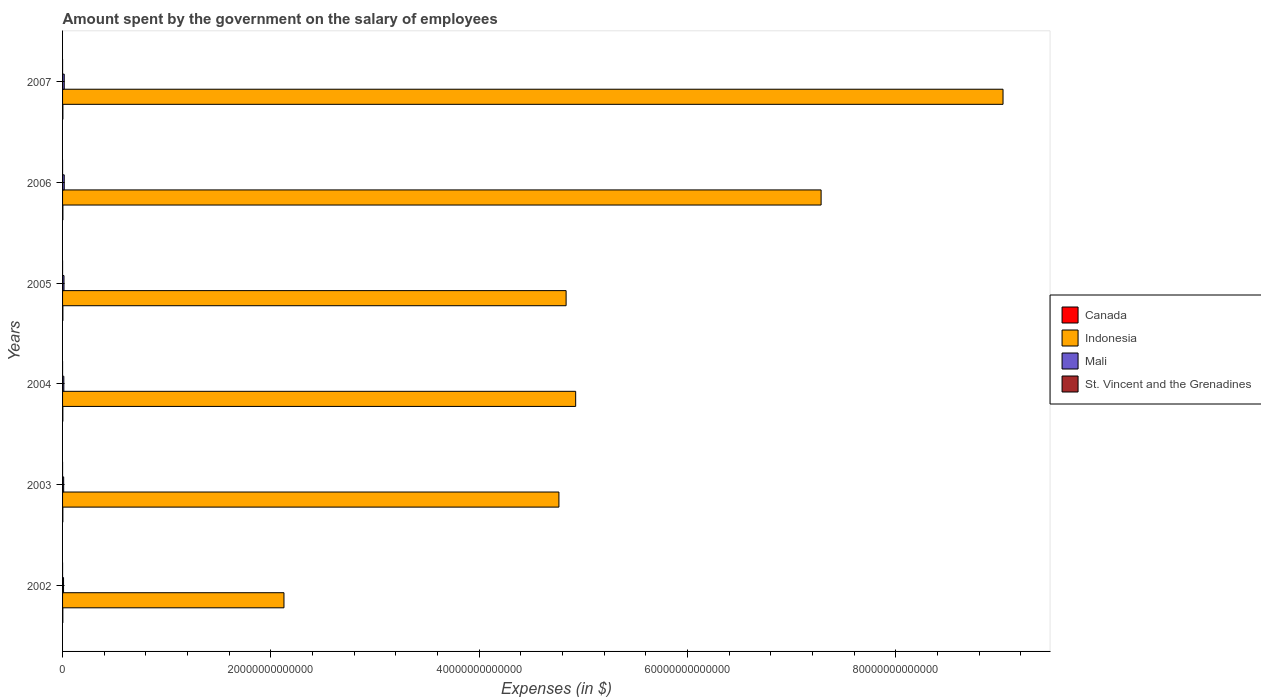How many bars are there on the 5th tick from the bottom?
Offer a very short reply. 4. In how many cases, is the number of bars for a given year not equal to the number of legend labels?
Your answer should be very brief. 0. What is the amount spent on the salary of employees by the government in Mali in 2005?
Your answer should be compact. 1.38e+11. Across all years, what is the maximum amount spent on the salary of employees by the government in Mali?
Keep it short and to the point. 1.60e+11. Across all years, what is the minimum amount spent on the salary of employees by the government in Canada?
Ensure brevity in your answer.  2.49e+1. In which year was the amount spent on the salary of employees by the government in Mali maximum?
Offer a very short reply. 2007. What is the total amount spent on the salary of employees by the government in St. Vincent and the Grenadines in the graph?
Give a very brief answer. 9.42e+08. What is the difference between the amount spent on the salary of employees by the government in Canada in 2003 and that in 2007?
Keep it short and to the point. -5.54e+09. What is the difference between the amount spent on the salary of employees by the government in Mali in 2006 and the amount spent on the salary of employees by the government in Indonesia in 2005?
Your response must be concise. -4.82e+13. What is the average amount spent on the salary of employees by the government in St. Vincent and the Grenadines per year?
Keep it short and to the point. 1.57e+08. In the year 2004, what is the difference between the amount spent on the salary of employees by the government in Canada and amount spent on the salary of employees by the government in Indonesia?
Ensure brevity in your answer.  -4.92e+13. What is the ratio of the amount spent on the salary of employees by the government in St. Vincent and the Grenadines in 2002 to that in 2005?
Ensure brevity in your answer.  0.87. Is the amount spent on the salary of employees by the government in St. Vincent and the Grenadines in 2006 less than that in 2007?
Provide a succinct answer. Yes. Is the difference between the amount spent on the salary of employees by the government in Canada in 2005 and 2006 greater than the difference between the amount spent on the salary of employees by the government in Indonesia in 2005 and 2006?
Make the answer very short. Yes. What is the difference between the highest and the second highest amount spent on the salary of employees by the government in St. Vincent and the Grenadines?
Your answer should be very brief. 1.77e+07. What is the difference between the highest and the lowest amount spent on the salary of employees by the government in Indonesia?
Your answer should be very brief. 6.90e+13. Is the sum of the amount spent on the salary of employees by the government in Mali in 2005 and 2007 greater than the maximum amount spent on the salary of employees by the government in Indonesia across all years?
Ensure brevity in your answer.  No. Is it the case that in every year, the sum of the amount spent on the salary of employees by the government in Mali and amount spent on the salary of employees by the government in Indonesia is greater than the sum of amount spent on the salary of employees by the government in St. Vincent and the Grenadines and amount spent on the salary of employees by the government in Canada?
Offer a very short reply. No. What does the 2nd bar from the top in 2007 represents?
Keep it short and to the point. Mali. Is it the case that in every year, the sum of the amount spent on the salary of employees by the government in St. Vincent and the Grenadines and amount spent on the salary of employees by the government in Canada is greater than the amount spent on the salary of employees by the government in Indonesia?
Your answer should be very brief. No. How many years are there in the graph?
Provide a short and direct response. 6. What is the difference between two consecutive major ticks on the X-axis?
Ensure brevity in your answer.  2.00e+13. Are the values on the major ticks of X-axis written in scientific E-notation?
Keep it short and to the point. No. Does the graph contain grids?
Keep it short and to the point. No. What is the title of the graph?
Offer a terse response. Amount spent by the government on the salary of employees. What is the label or title of the X-axis?
Make the answer very short. Expenses (in $). What is the Expenses (in $) of Canada in 2002?
Offer a terse response. 2.49e+1. What is the Expenses (in $) of Indonesia in 2002?
Provide a short and direct response. 2.13e+13. What is the Expenses (in $) of Mali in 2002?
Give a very brief answer. 9.35e+1. What is the Expenses (in $) in St. Vincent and the Grenadines in 2002?
Make the answer very short. 1.38e+08. What is the Expenses (in $) in Canada in 2003?
Your answer should be compact. 2.63e+1. What is the Expenses (in $) of Indonesia in 2003?
Provide a succinct answer. 4.77e+13. What is the Expenses (in $) of Mali in 2003?
Provide a short and direct response. 1.06e+11. What is the Expenses (in $) in St. Vincent and the Grenadines in 2003?
Offer a very short reply. 1.39e+08. What is the Expenses (in $) in Canada in 2004?
Give a very brief answer. 2.69e+1. What is the Expenses (in $) of Indonesia in 2004?
Provide a short and direct response. 4.93e+13. What is the Expenses (in $) of Mali in 2004?
Keep it short and to the point. 1.22e+11. What is the Expenses (in $) of St. Vincent and the Grenadines in 2004?
Your answer should be very brief. 1.45e+08. What is the Expenses (in $) in Canada in 2005?
Keep it short and to the point. 2.92e+1. What is the Expenses (in $) of Indonesia in 2005?
Offer a very short reply. 4.84e+13. What is the Expenses (in $) of Mali in 2005?
Provide a succinct answer. 1.38e+11. What is the Expenses (in $) of St. Vincent and the Grenadines in 2005?
Your response must be concise. 1.59e+08. What is the Expenses (in $) in Canada in 2006?
Your response must be concise. 3.06e+1. What is the Expenses (in $) of Indonesia in 2006?
Give a very brief answer. 7.28e+13. What is the Expenses (in $) of Mali in 2006?
Provide a succinct answer. 1.60e+11. What is the Expenses (in $) in St. Vincent and the Grenadines in 2006?
Offer a terse response. 1.71e+08. What is the Expenses (in $) of Canada in 2007?
Your answer should be compact. 3.18e+1. What is the Expenses (in $) of Indonesia in 2007?
Make the answer very short. 9.03e+13. What is the Expenses (in $) of Mali in 2007?
Give a very brief answer. 1.60e+11. What is the Expenses (in $) of St. Vincent and the Grenadines in 2007?
Your answer should be very brief. 1.89e+08. Across all years, what is the maximum Expenses (in $) in Canada?
Give a very brief answer. 3.18e+1. Across all years, what is the maximum Expenses (in $) of Indonesia?
Keep it short and to the point. 9.03e+13. Across all years, what is the maximum Expenses (in $) of Mali?
Your answer should be compact. 1.60e+11. Across all years, what is the maximum Expenses (in $) of St. Vincent and the Grenadines?
Ensure brevity in your answer.  1.89e+08. Across all years, what is the minimum Expenses (in $) in Canada?
Give a very brief answer. 2.49e+1. Across all years, what is the minimum Expenses (in $) of Indonesia?
Offer a very short reply. 2.13e+13. Across all years, what is the minimum Expenses (in $) in Mali?
Your response must be concise. 9.35e+1. Across all years, what is the minimum Expenses (in $) of St. Vincent and the Grenadines?
Keep it short and to the point. 1.38e+08. What is the total Expenses (in $) of Canada in the graph?
Make the answer very short. 1.70e+11. What is the total Expenses (in $) in Indonesia in the graph?
Offer a very short reply. 3.30e+14. What is the total Expenses (in $) of Mali in the graph?
Offer a terse response. 7.79e+11. What is the total Expenses (in $) of St. Vincent and the Grenadines in the graph?
Keep it short and to the point. 9.42e+08. What is the difference between the Expenses (in $) in Canada in 2002 and that in 2003?
Provide a short and direct response. -1.36e+09. What is the difference between the Expenses (in $) in Indonesia in 2002 and that in 2003?
Offer a terse response. -2.64e+13. What is the difference between the Expenses (in $) of Mali in 2002 and that in 2003?
Keep it short and to the point. -1.27e+1. What is the difference between the Expenses (in $) in St. Vincent and the Grenadines in 2002 and that in 2003?
Provide a short and direct response. -8.00e+05. What is the difference between the Expenses (in $) in Canada in 2002 and that in 2004?
Provide a succinct answer. -1.98e+09. What is the difference between the Expenses (in $) in Indonesia in 2002 and that in 2004?
Make the answer very short. -2.80e+13. What is the difference between the Expenses (in $) of Mali in 2002 and that in 2004?
Your answer should be very brief. -2.82e+1. What is the difference between the Expenses (in $) of St. Vincent and the Grenadines in 2002 and that in 2004?
Your response must be concise. -6.50e+06. What is the difference between the Expenses (in $) in Canada in 2002 and that in 2005?
Make the answer very short. -4.27e+09. What is the difference between the Expenses (in $) of Indonesia in 2002 and that in 2005?
Provide a succinct answer. -2.71e+13. What is the difference between the Expenses (in $) of Mali in 2002 and that in 2005?
Make the answer very short. -4.43e+1. What is the difference between the Expenses (in $) in St. Vincent and the Grenadines in 2002 and that in 2005?
Give a very brief answer. -2.08e+07. What is the difference between the Expenses (in $) in Canada in 2002 and that in 2006?
Your response must be concise. -5.63e+09. What is the difference between the Expenses (in $) of Indonesia in 2002 and that in 2006?
Your answer should be very brief. -5.16e+13. What is the difference between the Expenses (in $) in Mali in 2002 and that in 2006?
Offer a very short reply. -6.61e+1. What is the difference between the Expenses (in $) in St. Vincent and the Grenadines in 2002 and that in 2006?
Offer a terse response. -3.30e+07. What is the difference between the Expenses (in $) of Canada in 2002 and that in 2007?
Ensure brevity in your answer.  -6.90e+09. What is the difference between the Expenses (in $) in Indonesia in 2002 and that in 2007?
Your answer should be compact. -6.90e+13. What is the difference between the Expenses (in $) of Mali in 2002 and that in 2007?
Make the answer very short. -6.68e+1. What is the difference between the Expenses (in $) in St. Vincent and the Grenadines in 2002 and that in 2007?
Offer a terse response. -5.07e+07. What is the difference between the Expenses (in $) in Canada in 2003 and that in 2004?
Keep it short and to the point. -6.14e+08. What is the difference between the Expenses (in $) in Indonesia in 2003 and that in 2004?
Your response must be concise. -1.61e+12. What is the difference between the Expenses (in $) of Mali in 2003 and that in 2004?
Keep it short and to the point. -1.55e+1. What is the difference between the Expenses (in $) of St. Vincent and the Grenadines in 2003 and that in 2004?
Your response must be concise. -5.70e+06. What is the difference between the Expenses (in $) in Canada in 2003 and that in 2005?
Provide a succinct answer. -2.90e+09. What is the difference between the Expenses (in $) in Indonesia in 2003 and that in 2005?
Provide a short and direct response. -6.89e+11. What is the difference between the Expenses (in $) in Mali in 2003 and that in 2005?
Offer a very short reply. -3.16e+1. What is the difference between the Expenses (in $) in St. Vincent and the Grenadines in 2003 and that in 2005?
Ensure brevity in your answer.  -2.00e+07. What is the difference between the Expenses (in $) in Canada in 2003 and that in 2006?
Your response must be concise. -4.26e+09. What is the difference between the Expenses (in $) of Indonesia in 2003 and that in 2006?
Offer a terse response. -2.52e+13. What is the difference between the Expenses (in $) in Mali in 2003 and that in 2006?
Your answer should be very brief. -5.34e+1. What is the difference between the Expenses (in $) in St. Vincent and the Grenadines in 2003 and that in 2006?
Ensure brevity in your answer.  -3.22e+07. What is the difference between the Expenses (in $) in Canada in 2003 and that in 2007?
Give a very brief answer. -5.54e+09. What is the difference between the Expenses (in $) of Indonesia in 2003 and that in 2007?
Provide a succinct answer. -4.26e+13. What is the difference between the Expenses (in $) in Mali in 2003 and that in 2007?
Keep it short and to the point. -5.41e+1. What is the difference between the Expenses (in $) in St. Vincent and the Grenadines in 2003 and that in 2007?
Provide a succinct answer. -4.99e+07. What is the difference between the Expenses (in $) in Canada in 2004 and that in 2005?
Offer a very short reply. -2.29e+09. What is the difference between the Expenses (in $) in Indonesia in 2004 and that in 2005?
Give a very brief answer. 9.19e+11. What is the difference between the Expenses (in $) of Mali in 2004 and that in 2005?
Keep it short and to the point. -1.61e+1. What is the difference between the Expenses (in $) of St. Vincent and the Grenadines in 2004 and that in 2005?
Ensure brevity in your answer.  -1.43e+07. What is the difference between the Expenses (in $) of Canada in 2004 and that in 2006?
Your answer should be compact. -3.65e+09. What is the difference between the Expenses (in $) in Indonesia in 2004 and that in 2006?
Provide a short and direct response. -2.36e+13. What is the difference between the Expenses (in $) of Mali in 2004 and that in 2006?
Make the answer very short. -3.79e+1. What is the difference between the Expenses (in $) in St. Vincent and the Grenadines in 2004 and that in 2006?
Offer a terse response. -2.65e+07. What is the difference between the Expenses (in $) of Canada in 2004 and that in 2007?
Offer a terse response. -4.92e+09. What is the difference between the Expenses (in $) of Indonesia in 2004 and that in 2007?
Ensure brevity in your answer.  -4.10e+13. What is the difference between the Expenses (in $) of Mali in 2004 and that in 2007?
Make the answer very short. -3.86e+1. What is the difference between the Expenses (in $) in St. Vincent and the Grenadines in 2004 and that in 2007?
Keep it short and to the point. -4.42e+07. What is the difference between the Expenses (in $) in Canada in 2005 and that in 2006?
Your answer should be compact. -1.36e+09. What is the difference between the Expenses (in $) of Indonesia in 2005 and that in 2006?
Make the answer very short. -2.45e+13. What is the difference between the Expenses (in $) in Mali in 2005 and that in 2006?
Your response must be concise. -2.18e+1. What is the difference between the Expenses (in $) of St. Vincent and the Grenadines in 2005 and that in 2006?
Give a very brief answer. -1.22e+07. What is the difference between the Expenses (in $) of Canada in 2005 and that in 2007?
Your response must be concise. -2.63e+09. What is the difference between the Expenses (in $) of Indonesia in 2005 and that in 2007?
Make the answer very short. -4.20e+13. What is the difference between the Expenses (in $) in Mali in 2005 and that in 2007?
Keep it short and to the point. -2.25e+1. What is the difference between the Expenses (in $) in St. Vincent and the Grenadines in 2005 and that in 2007?
Provide a succinct answer. -2.99e+07. What is the difference between the Expenses (in $) in Canada in 2006 and that in 2007?
Your answer should be very brief. -1.27e+09. What is the difference between the Expenses (in $) in Indonesia in 2006 and that in 2007?
Your answer should be very brief. -1.75e+13. What is the difference between the Expenses (in $) of Mali in 2006 and that in 2007?
Offer a terse response. -7.02e+08. What is the difference between the Expenses (in $) of St. Vincent and the Grenadines in 2006 and that in 2007?
Keep it short and to the point. -1.77e+07. What is the difference between the Expenses (in $) in Canada in 2002 and the Expenses (in $) in Indonesia in 2003?
Ensure brevity in your answer.  -4.76e+13. What is the difference between the Expenses (in $) in Canada in 2002 and the Expenses (in $) in Mali in 2003?
Provide a succinct answer. -8.13e+1. What is the difference between the Expenses (in $) in Canada in 2002 and the Expenses (in $) in St. Vincent and the Grenadines in 2003?
Give a very brief answer. 2.48e+1. What is the difference between the Expenses (in $) of Indonesia in 2002 and the Expenses (in $) of Mali in 2003?
Provide a succinct answer. 2.12e+13. What is the difference between the Expenses (in $) of Indonesia in 2002 and the Expenses (in $) of St. Vincent and the Grenadines in 2003?
Offer a terse response. 2.13e+13. What is the difference between the Expenses (in $) of Mali in 2002 and the Expenses (in $) of St. Vincent and the Grenadines in 2003?
Give a very brief answer. 9.34e+1. What is the difference between the Expenses (in $) of Canada in 2002 and the Expenses (in $) of Indonesia in 2004?
Your response must be concise. -4.92e+13. What is the difference between the Expenses (in $) in Canada in 2002 and the Expenses (in $) in Mali in 2004?
Your answer should be compact. -9.68e+1. What is the difference between the Expenses (in $) of Canada in 2002 and the Expenses (in $) of St. Vincent and the Grenadines in 2004?
Your response must be concise. 2.48e+1. What is the difference between the Expenses (in $) of Indonesia in 2002 and the Expenses (in $) of Mali in 2004?
Ensure brevity in your answer.  2.11e+13. What is the difference between the Expenses (in $) of Indonesia in 2002 and the Expenses (in $) of St. Vincent and the Grenadines in 2004?
Ensure brevity in your answer.  2.13e+13. What is the difference between the Expenses (in $) of Mali in 2002 and the Expenses (in $) of St. Vincent and the Grenadines in 2004?
Your answer should be very brief. 9.33e+1. What is the difference between the Expenses (in $) in Canada in 2002 and the Expenses (in $) in Indonesia in 2005?
Offer a terse response. -4.83e+13. What is the difference between the Expenses (in $) of Canada in 2002 and the Expenses (in $) of Mali in 2005?
Provide a succinct answer. -1.13e+11. What is the difference between the Expenses (in $) in Canada in 2002 and the Expenses (in $) in St. Vincent and the Grenadines in 2005?
Keep it short and to the point. 2.48e+1. What is the difference between the Expenses (in $) in Indonesia in 2002 and the Expenses (in $) in Mali in 2005?
Provide a short and direct response. 2.11e+13. What is the difference between the Expenses (in $) in Indonesia in 2002 and the Expenses (in $) in St. Vincent and the Grenadines in 2005?
Your answer should be compact. 2.13e+13. What is the difference between the Expenses (in $) of Mali in 2002 and the Expenses (in $) of St. Vincent and the Grenadines in 2005?
Provide a short and direct response. 9.33e+1. What is the difference between the Expenses (in $) of Canada in 2002 and the Expenses (in $) of Indonesia in 2006?
Provide a short and direct response. -7.28e+13. What is the difference between the Expenses (in $) in Canada in 2002 and the Expenses (in $) in Mali in 2006?
Ensure brevity in your answer.  -1.35e+11. What is the difference between the Expenses (in $) of Canada in 2002 and the Expenses (in $) of St. Vincent and the Grenadines in 2006?
Provide a succinct answer. 2.48e+1. What is the difference between the Expenses (in $) of Indonesia in 2002 and the Expenses (in $) of Mali in 2006?
Your response must be concise. 2.11e+13. What is the difference between the Expenses (in $) in Indonesia in 2002 and the Expenses (in $) in St. Vincent and the Grenadines in 2006?
Offer a terse response. 2.13e+13. What is the difference between the Expenses (in $) in Mali in 2002 and the Expenses (in $) in St. Vincent and the Grenadines in 2006?
Ensure brevity in your answer.  9.33e+1. What is the difference between the Expenses (in $) in Canada in 2002 and the Expenses (in $) in Indonesia in 2007?
Offer a terse response. -9.03e+13. What is the difference between the Expenses (in $) of Canada in 2002 and the Expenses (in $) of Mali in 2007?
Your response must be concise. -1.35e+11. What is the difference between the Expenses (in $) of Canada in 2002 and the Expenses (in $) of St. Vincent and the Grenadines in 2007?
Offer a terse response. 2.48e+1. What is the difference between the Expenses (in $) of Indonesia in 2002 and the Expenses (in $) of Mali in 2007?
Provide a short and direct response. 2.11e+13. What is the difference between the Expenses (in $) of Indonesia in 2002 and the Expenses (in $) of St. Vincent and the Grenadines in 2007?
Your answer should be compact. 2.13e+13. What is the difference between the Expenses (in $) of Mali in 2002 and the Expenses (in $) of St. Vincent and the Grenadines in 2007?
Ensure brevity in your answer.  9.33e+1. What is the difference between the Expenses (in $) in Canada in 2003 and the Expenses (in $) in Indonesia in 2004?
Ensure brevity in your answer.  -4.92e+13. What is the difference between the Expenses (in $) in Canada in 2003 and the Expenses (in $) in Mali in 2004?
Your response must be concise. -9.54e+1. What is the difference between the Expenses (in $) in Canada in 2003 and the Expenses (in $) in St. Vincent and the Grenadines in 2004?
Your answer should be compact. 2.62e+1. What is the difference between the Expenses (in $) in Indonesia in 2003 and the Expenses (in $) in Mali in 2004?
Ensure brevity in your answer.  4.75e+13. What is the difference between the Expenses (in $) of Indonesia in 2003 and the Expenses (in $) of St. Vincent and the Grenadines in 2004?
Your answer should be very brief. 4.77e+13. What is the difference between the Expenses (in $) of Mali in 2003 and the Expenses (in $) of St. Vincent and the Grenadines in 2004?
Keep it short and to the point. 1.06e+11. What is the difference between the Expenses (in $) of Canada in 2003 and the Expenses (in $) of Indonesia in 2005?
Offer a very short reply. -4.83e+13. What is the difference between the Expenses (in $) in Canada in 2003 and the Expenses (in $) in Mali in 2005?
Your response must be concise. -1.11e+11. What is the difference between the Expenses (in $) of Canada in 2003 and the Expenses (in $) of St. Vincent and the Grenadines in 2005?
Ensure brevity in your answer.  2.62e+1. What is the difference between the Expenses (in $) of Indonesia in 2003 and the Expenses (in $) of Mali in 2005?
Your response must be concise. 4.75e+13. What is the difference between the Expenses (in $) of Indonesia in 2003 and the Expenses (in $) of St. Vincent and the Grenadines in 2005?
Ensure brevity in your answer.  4.77e+13. What is the difference between the Expenses (in $) of Mali in 2003 and the Expenses (in $) of St. Vincent and the Grenadines in 2005?
Your answer should be very brief. 1.06e+11. What is the difference between the Expenses (in $) of Canada in 2003 and the Expenses (in $) of Indonesia in 2006?
Give a very brief answer. -7.28e+13. What is the difference between the Expenses (in $) of Canada in 2003 and the Expenses (in $) of Mali in 2006?
Make the answer very short. -1.33e+11. What is the difference between the Expenses (in $) of Canada in 2003 and the Expenses (in $) of St. Vincent and the Grenadines in 2006?
Ensure brevity in your answer.  2.61e+1. What is the difference between the Expenses (in $) of Indonesia in 2003 and the Expenses (in $) of Mali in 2006?
Offer a very short reply. 4.75e+13. What is the difference between the Expenses (in $) of Indonesia in 2003 and the Expenses (in $) of St. Vincent and the Grenadines in 2006?
Offer a terse response. 4.77e+13. What is the difference between the Expenses (in $) in Mali in 2003 and the Expenses (in $) in St. Vincent and the Grenadines in 2006?
Your response must be concise. 1.06e+11. What is the difference between the Expenses (in $) in Canada in 2003 and the Expenses (in $) in Indonesia in 2007?
Provide a succinct answer. -9.03e+13. What is the difference between the Expenses (in $) in Canada in 2003 and the Expenses (in $) in Mali in 2007?
Give a very brief answer. -1.34e+11. What is the difference between the Expenses (in $) in Canada in 2003 and the Expenses (in $) in St. Vincent and the Grenadines in 2007?
Provide a succinct answer. 2.61e+1. What is the difference between the Expenses (in $) of Indonesia in 2003 and the Expenses (in $) of Mali in 2007?
Keep it short and to the point. 4.75e+13. What is the difference between the Expenses (in $) of Indonesia in 2003 and the Expenses (in $) of St. Vincent and the Grenadines in 2007?
Offer a terse response. 4.77e+13. What is the difference between the Expenses (in $) in Mali in 2003 and the Expenses (in $) in St. Vincent and the Grenadines in 2007?
Ensure brevity in your answer.  1.06e+11. What is the difference between the Expenses (in $) of Canada in 2004 and the Expenses (in $) of Indonesia in 2005?
Your answer should be compact. -4.83e+13. What is the difference between the Expenses (in $) in Canada in 2004 and the Expenses (in $) in Mali in 2005?
Make the answer very short. -1.11e+11. What is the difference between the Expenses (in $) of Canada in 2004 and the Expenses (in $) of St. Vincent and the Grenadines in 2005?
Provide a short and direct response. 2.68e+1. What is the difference between the Expenses (in $) of Indonesia in 2004 and the Expenses (in $) of Mali in 2005?
Offer a terse response. 4.91e+13. What is the difference between the Expenses (in $) in Indonesia in 2004 and the Expenses (in $) in St. Vincent and the Grenadines in 2005?
Offer a terse response. 4.93e+13. What is the difference between the Expenses (in $) of Mali in 2004 and the Expenses (in $) of St. Vincent and the Grenadines in 2005?
Your response must be concise. 1.22e+11. What is the difference between the Expenses (in $) of Canada in 2004 and the Expenses (in $) of Indonesia in 2006?
Offer a very short reply. -7.28e+13. What is the difference between the Expenses (in $) in Canada in 2004 and the Expenses (in $) in Mali in 2006?
Offer a very short reply. -1.33e+11. What is the difference between the Expenses (in $) in Canada in 2004 and the Expenses (in $) in St. Vincent and the Grenadines in 2006?
Provide a succinct answer. 2.68e+1. What is the difference between the Expenses (in $) of Indonesia in 2004 and the Expenses (in $) of Mali in 2006?
Your response must be concise. 4.91e+13. What is the difference between the Expenses (in $) in Indonesia in 2004 and the Expenses (in $) in St. Vincent and the Grenadines in 2006?
Keep it short and to the point. 4.93e+13. What is the difference between the Expenses (in $) in Mali in 2004 and the Expenses (in $) in St. Vincent and the Grenadines in 2006?
Make the answer very short. 1.22e+11. What is the difference between the Expenses (in $) in Canada in 2004 and the Expenses (in $) in Indonesia in 2007?
Your answer should be compact. -9.03e+13. What is the difference between the Expenses (in $) in Canada in 2004 and the Expenses (in $) in Mali in 2007?
Give a very brief answer. -1.33e+11. What is the difference between the Expenses (in $) of Canada in 2004 and the Expenses (in $) of St. Vincent and the Grenadines in 2007?
Provide a succinct answer. 2.67e+1. What is the difference between the Expenses (in $) of Indonesia in 2004 and the Expenses (in $) of Mali in 2007?
Provide a short and direct response. 4.91e+13. What is the difference between the Expenses (in $) of Indonesia in 2004 and the Expenses (in $) of St. Vincent and the Grenadines in 2007?
Offer a very short reply. 4.93e+13. What is the difference between the Expenses (in $) of Mali in 2004 and the Expenses (in $) of St. Vincent and the Grenadines in 2007?
Your answer should be very brief. 1.22e+11. What is the difference between the Expenses (in $) of Canada in 2005 and the Expenses (in $) of Indonesia in 2006?
Give a very brief answer. -7.28e+13. What is the difference between the Expenses (in $) of Canada in 2005 and the Expenses (in $) of Mali in 2006?
Your answer should be compact. -1.30e+11. What is the difference between the Expenses (in $) in Canada in 2005 and the Expenses (in $) in St. Vincent and the Grenadines in 2006?
Give a very brief answer. 2.90e+1. What is the difference between the Expenses (in $) in Indonesia in 2005 and the Expenses (in $) in Mali in 2006?
Offer a very short reply. 4.82e+13. What is the difference between the Expenses (in $) in Indonesia in 2005 and the Expenses (in $) in St. Vincent and the Grenadines in 2006?
Offer a very short reply. 4.84e+13. What is the difference between the Expenses (in $) in Mali in 2005 and the Expenses (in $) in St. Vincent and the Grenadines in 2006?
Ensure brevity in your answer.  1.38e+11. What is the difference between the Expenses (in $) in Canada in 2005 and the Expenses (in $) in Indonesia in 2007?
Offer a very short reply. -9.03e+13. What is the difference between the Expenses (in $) in Canada in 2005 and the Expenses (in $) in Mali in 2007?
Offer a terse response. -1.31e+11. What is the difference between the Expenses (in $) in Canada in 2005 and the Expenses (in $) in St. Vincent and the Grenadines in 2007?
Ensure brevity in your answer.  2.90e+1. What is the difference between the Expenses (in $) in Indonesia in 2005 and the Expenses (in $) in Mali in 2007?
Offer a very short reply. 4.82e+13. What is the difference between the Expenses (in $) of Indonesia in 2005 and the Expenses (in $) of St. Vincent and the Grenadines in 2007?
Your answer should be very brief. 4.84e+13. What is the difference between the Expenses (in $) in Mali in 2005 and the Expenses (in $) in St. Vincent and the Grenadines in 2007?
Offer a terse response. 1.38e+11. What is the difference between the Expenses (in $) in Canada in 2006 and the Expenses (in $) in Indonesia in 2007?
Make the answer very short. -9.03e+13. What is the difference between the Expenses (in $) of Canada in 2006 and the Expenses (in $) of Mali in 2007?
Provide a succinct answer. -1.30e+11. What is the difference between the Expenses (in $) of Canada in 2006 and the Expenses (in $) of St. Vincent and the Grenadines in 2007?
Keep it short and to the point. 3.04e+1. What is the difference between the Expenses (in $) of Indonesia in 2006 and the Expenses (in $) of Mali in 2007?
Make the answer very short. 7.27e+13. What is the difference between the Expenses (in $) in Indonesia in 2006 and the Expenses (in $) in St. Vincent and the Grenadines in 2007?
Provide a succinct answer. 7.28e+13. What is the difference between the Expenses (in $) of Mali in 2006 and the Expenses (in $) of St. Vincent and the Grenadines in 2007?
Provide a succinct answer. 1.59e+11. What is the average Expenses (in $) in Canada per year?
Your response must be concise. 2.83e+1. What is the average Expenses (in $) of Indonesia per year?
Keep it short and to the point. 5.49e+13. What is the average Expenses (in $) in Mali per year?
Offer a terse response. 1.30e+11. What is the average Expenses (in $) of St. Vincent and the Grenadines per year?
Offer a terse response. 1.57e+08. In the year 2002, what is the difference between the Expenses (in $) in Canada and Expenses (in $) in Indonesia?
Keep it short and to the point. -2.12e+13. In the year 2002, what is the difference between the Expenses (in $) in Canada and Expenses (in $) in Mali?
Give a very brief answer. -6.85e+1. In the year 2002, what is the difference between the Expenses (in $) in Canada and Expenses (in $) in St. Vincent and the Grenadines?
Provide a succinct answer. 2.48e+1. In the year 2002, what is the difference between the Expenses (in $) of Indonesia and Expenses (in $) of Mali?
Ensure brevity in your answer.  2.12e+13. In the year 2002, what is the difference between the Expenses (in $) of Indonesia and Expenses (in $) of St. Vincent and the Grenadines?
Your answer should be compact. 2.13e+13. In the year 2002, what is the difference between the Expenses (in $) in Mali and Expenses (in $) in St. Vincent and the Grenadines?
Give a very brief answer. 9.34e+1. In the year 2003, what is the difference between the Expenses (in $) of Canada and Expenses (in $) of Indonesia?
Make the answer very short. -4.76e+13. In the year 2003, what is the difference between the Expenses (in $) of Canada and Expenses (in $) of Mali?
Provide a succinct answer. -7.99e+1. In the year 2003, what is the difference between the Expenses (in $) of Canada and Expenses (in $) of St. Vincent and the Grenadines?
Offer a very short reply. 2.62e+1. In the year 2003, what is the difference between the Expenses (in $) of Indonesia and Expenses (in $) of Mali?
Keep it short and to the point. 4.76e+13. In the year 2003, what is the difference between the Expenses (in $) in Indonesia and Expenses (in $) in St. Vincent and the Grenadines?
Your answer should be very brief. 4.77e+13. In the year 2003, what is the difference between the Expenses (in $) in Mali and Expenses (in $) in St. Vincent and the Grenadines?
Offer a terse response. 1.06e+11. In the year 2004, what is the difference between the Expenses (in $) of Canada and Expenses (in $) of Indonesia?
Make the answer very short. -4.92e+13. In the year 2004, what is the difference between the Expenses (in $) of Canada and Expenses (in $) of Mali?
Provide a succinct answer. -9.48e+1. In the year 2004, what is the difference between the Expenses (in $) in Canada and Expenses (in $) in St. Vincent and the Grenadines?
Your response must be concise. 2.68e+1. In the year 2004, what is the difference between the Expenses (in $) of Indonesia and Expenses (in $) of Mali?
Your answer should be compact. 4.91e+13. In the year 2004, what is the difference between the Expenses (in $) in Indonesia and Expenses (in $) in St. Vincent and the Grenadines?
Make the answer very short. 4.93e+13. In the year 2004, what is the difference between the Expenses (in $) in Mali and Expenses (in $) in St. Vincent and the Grenadines?
Your answer should be compact. 1.22e+11. In the year 2005, what is the difference between the Expenses (in $) in Canada and Expenses (in $) in Indonesia?
Your answer should be compact. -4.83e+13. In the year 2005, what is the difference between the Expenses (in $) in Canada and Expenses (in $) in Mali?
Your answer should be compact. -1.09e+11. In the year 2005, what is the difference between the Expenses (in $) of Canada and Expenses (in $) of St. Vincent and the Grenadines?
Provide a short and direct response. 2.91e+1. In the year 2005, what is the difference between the Expenses (in $) in Indonesia and Expenses (in $) in Mali?
Your answer should be very brief. 4.82e+13. In the year 2005, what is the difference between the Expenses (in $) in Indonesia and Expenses (in $) in St. Vincent and the Grenadines?
Ensure brevity in your answer.  4.84e+13. In the year 2005, what is the difference between the Expenses (in $) of Mali and Expenses (in $) of St. Vincent and the Grenadines?
Keep it short and to the point. 1.38e+11. In the year 2006, what is the difference between the Expenses (in $) of Canada and Expenses (in $) of Indonesia?
Provide a succinct answer. -7.28e+13. In the year 2006, what is the difference between the Expenses (in $) in Canada and Expenses (in $) in Mali?
Provide a succinct answer. -1.29e+11. In the year 2006, what is the difference between the Expenses (in $) in Canada and Expenses (in $) in St. Vincent and the Grenadines?
Ensure brevity in your answer.  3.04e+1. In the year 2006, what is the difference between the Expenses (in $) of Indonesia and Expenses (in $) of Mali?
Make the answer very short. 7.27e+13. In the year 2006, what is the difference between the Expenses (in $) of Indonesia and Expenses (in $) of St. Vincent and the Grenadines?
Make the answer very short. 7.28e+13. In the year 2006, what is the difference between the Expenses (in $) in Mali and Expenses (in $) in St. Vincent and the Grenadines?
Keep it short and to the point. 1.59e+11. In the year 2007, what is the difference between the Expenses (in $) in Canada and Expenses (in $) in Indonesia?
Offer a terse response. -9.03e+13. In the year 2007, what is the difference between the Expenses (in $) of Canada and Expenses (in $) of Mali?
Your response must be concise. -1.28e+11. In the year 2007, what is the difference between the Expenses (in $) of Canada and Expenses (in $) of St. Vincent and the Grenadines?
Your answer should be compact. 3.17e+1. In the year 2007, what is the difference between the Expenses (in $) in Indonesia and Expenses (in $) in Mali?
Ensure brevity in your answer.  9.01e+13. In the year 2007, what is the difference between the Expenses (in $) in Indonesia and Expenses (in $) in St. Vincent and the Grenadines?
Offer a very short reply. 9.03e+13. In the year 2007, what is the difference between the Expenses (in $) in Mali and Expenses (in $) in St. Vincent and the Grenadines?
Your answer should be compact. 1.60e+11. What is the ratio of the Expenses (in $) of Canada in 2002 to that in 2003?
Give a very brief answer. 0.95. What is the ratio of the Expenses (in $) in Indonesia in 2002 to that in 2003?
Your response must be concise. 0.45. What is the ratio of the Expenses (in $) in Mali in 2002 to that in 2003?
Offer a terse response. 0.88. What is the ratio of the Expenses (in $) in Canada in 2002 to that in 2004?
Ensure brevity in your answer.  0.93. What is the ratio of the Expenses (in $) of Indonesia in 2002 to that in 2004?
Provide a short and direct response. 0.43. What is the ratio of the Expenses (in $) in Mali in 2002 to that in 2004?
Your response must be concise. 0.77. What is the ratio of the Expenses (in $) of St. Vincent and the Grenadines in 2002 to that in 2004?
Keep it short and to the point. 0.96. What is the ratio of the Expenses (in $) in Canada in 2002 to that in 2005?
Your answer should be compact. 0.85. What is the ratio of the Expenses (in $) of Indonesia in 2002 to that in 2005?
Your response must be concise. 0.44. What is the ratio of the Expenses (in $) of Mali in 2002 to that in 2005?
Give a very brief answer. 0.68. What is the ratio of the Expenses (in $) of St. Vincent and the Grenadines in 2002 to that in 2005?
Keep it short and to the point. 0.87. What is the ratio of the Expenses (in $) in Canada in 2002 to that in 2006?
Provide a succinct answer. 0.82. What is the ratio of the Expenses (in $) in Indonesia in 2002 to that in 2006?
Offer a terse response. 0.29. What is the ratio of the Expenses (in $) in Mali in 2002 to that in 2006?
Provide a succinct answer. 0.59. What is the ratio of the Expenses (in $) in St. Vincent and the Grenadines in 2002 to that in 2006?
Your answer should be compact. 0.81. What is the ratio of the Expenses (in $) in Canada in 2002 to that in 2007?
Keep it short and to the point. 0.78. What is the ratio of the Expenses (in $) in Indonesia in 2002 to that in 2007?
Ensure brevity in your answer.  0.24. What is the ratio of the Expenses (in $) of Mali in 2002 to that in 2007?
Your answer should be very brief. 0.58. What is the ratio of the Expenses (in $) of St. Vincent and the Grenadines in 2002 to that in 2007?
Your answer should be compact. 0.73. What is the ratio of the Expenses (in $) in Canada in 2003 to that in 2004?
Offer a terse response. 0.98. What is the ratio of the Expenses (in $) of Indonesia in 2003 to that in 2004?
Ensure brevity in your answer.  0.97. What is the ratio of the Expenses (in $) of Mali in 2003 to that in 2004?
Your answer should be compact. 0.87. What is the ratio of the Expenses (in $) of St. Vincent and the Grenadines in 2003 to that in 2004?
Offer a very short reply. 0.96. What is the ratio of the Expenses (in $) of Canada in 2003 to that in 2005?
Your answer should be compact. 0.9. What is the ratio of the Expenses (in $) in Indonesia in 2003 to that in 2005?
Provide a succinct answer. 0.99. What is the ratio of the Expenses (in $) of Mali in 2003 to that in 2005?
Your answer should be very brief. 0.77. What is the ratio of the Expenses (in $) of St. Vincent and the Grenadines in 2003 to that in 2005?
Provide a succinct answer. 0.87. What is the ratio of the Expenses (in $) in Canada in 2003 to that in 2006?
Keep it short and to the point. 0.86. What is the ratio of the Expenses (in $) in Indonesia in 2003 to that in 2006?
Keep it short and to the point. 0.65. What is the ratio of the Expenses (in $) of Mali in 2003 to that in 2006?
Offer a very short reply. 0.67. What is the ratio of the Expenses (in $) of St. Vincent and the Grenadines in 2003 to that in 2006?
Make the answer very short. 0.81. What is the ratio of the Expenses (in $) of Canada in 2003 to that in 2007?
Provide a succinct answer. 0.83. What is the ratio of the Expenses (in $) in Indonesia in 2003 to that in 2007?
Keep it short and to the point. 0.53. What is the ratio of the Expenses (in $) in Mali in 2003 to that in 2007?
Make the answer very short. 0.66. What is the ratio of the Expenses (in $) in St. Vincent and the Grenadines in 2003 to that in 2007?
Your response must be concise. 0.74. What is the ratio of the Expenses (in $) of Canada in 2004 to that in 2005?
Your response must be concise. 0.92. What is the ratio of the Expenses (in $) in Indonesia in 2004 to that in 2005?
Make the answer very short. 1.02. What is the ratio of the Expenses (in $) in Mali in 2004 to that in 2005?
Your response must be concise. 0.88. What is the ratio of the Expenses (in $) in St. Vincent and the Grenadines in 2004 to that in 2005?
Ensure brevity in your answer.  0.91. What is the ratio of the Expenses (in $) of Canada in 2004 to that in 2006?
Your response must be concise. 0.88. What is the ratio of the Expenses (in $) of Indonesia in 2004 to that in 2006?
Offer a terse response. 0.68. What is the ratio of the Expenses (in $) in Mali in 2004 to that in 2006?
Your response must be concise. 0.76. What is the ratio of the Expenses (in $) of St. Vincent and the Grenadines in 2004 to that in 2006?
Your response must be concise. 0.85. What is the ratio of the Expenses (in $) in Canada in 2004 to that in 2007?
Keep it short and to the point. 0.85. What is the ratio of the Expenses (in $) of Indonesia in 2004 to that in 2007?
Provide a short and direct response. 0.55. What is the ratio of the Expenses (in $) in Mali in 2004 to that in 2007?
Ensure brevity in your answer.  0.76. What is the ratio of the Expenses (in $) of St. Vincent and the Grenadines in 2004 to that in 2007?
Ensure brevity in your answer.  0.77. What is the ratio of the Expenses (in $) of Canada in 2005 to that in 2006?
Give a very brief answer. 0.96. What is the ratio of the Expenses (in $) of Indonesia in 2005 to that in 2006?
Keep it short and to the point. 0.66. What is the ratio of the Expenses (in $) in Mali in 2005 to that in 2006?
Your response must be concise. 0.86. What is the ratio of the Expenses (in $) of St. Vincent and the Grenadines in 2005 to that in 2006?
Give a very brief answer. 0.93. What is the ratio of the Expenses (in $) of Canada in 2005 to that in 2007?
Offer a terse response. 0.92. What is the ratio of the Expenses (in $) of Indonesia in 2005 to that in 2007?
Ensure brevity in your answer.  0.54. What is the ratio of the Expenses (in $) of Mali in 2005 to that in 2007?
Your answer should be compact. 0.86. What is the ratio of the Expenses (in $) in St. Vincent and the Grenadines in 2005 to that in 2007?
Make the answer very short. 0.84. What is the ratio of the Expenses (in $) in Canada in 2006 to that in 2007?
Your response must be concise. 0.96. What is the ratio of the Expenses (in $) of Indonesia in 2006 to that in 2007?
Your answer should be compact. 0.81. What is the ratio of the Expenses (in $) of Mali in 2006 to that in 2007?
Your answer should be very brief. 1. What is the ratio of the Expenses (in $) in St. Vincent and the Grenadines in 2006 to that in 2007?
Your answer should be compact. 0.91. What is the difference between the highest and the second highest Expenses (in $) of Canada?
Give a very brief answer. 1.27e+09. What is the difference between the highest and the second highest Expenses (in $) of Indonesia?
Offer a terse response. 1.75e+13. What is the difference between the highest and the second highest Expenses (in $) in Mali?
Provide a succinct answer. 7.02e+08. What is the difference between the highest and the second highest Expenses (in $) of St. Vincent and the Grenadines?
Ensure brevity in your answer.  1.77e+07. What is the difference between the highest and the lowest Expenses (in $) in Canada?
Provide a succinct answer. 6.90e+09. What is the difference between the highest and the lowest Expenses (in $) of Indonesia?
Keep it short and to the point. 6.90e+13. What is the difference between the highest and the lowest Expenses (in $) in Mali?
Provide a succinct answer. 6.68e+1. What is the difference between the highest and the lowest Expenses (in $) of St. Vincent and the Grenadines?
Your answer should be compact. 5.07e+07. 